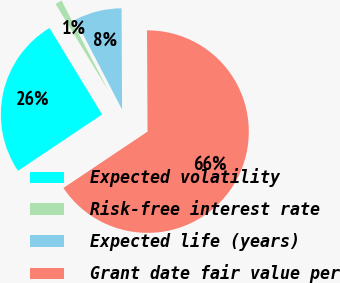Convert chart to OTSL. <chart><loc_0><loc_0><loc_500><loc_500><pie_chart><fcel>Expected volatility<fcel>Risk-free interest rate<fcel>Expected life (years)<fcel>Grant date fair value per<nl><fcel>25.69%<fcel>1.08%<fcel>7.54%<fcel>65.68%<nl></chart> 